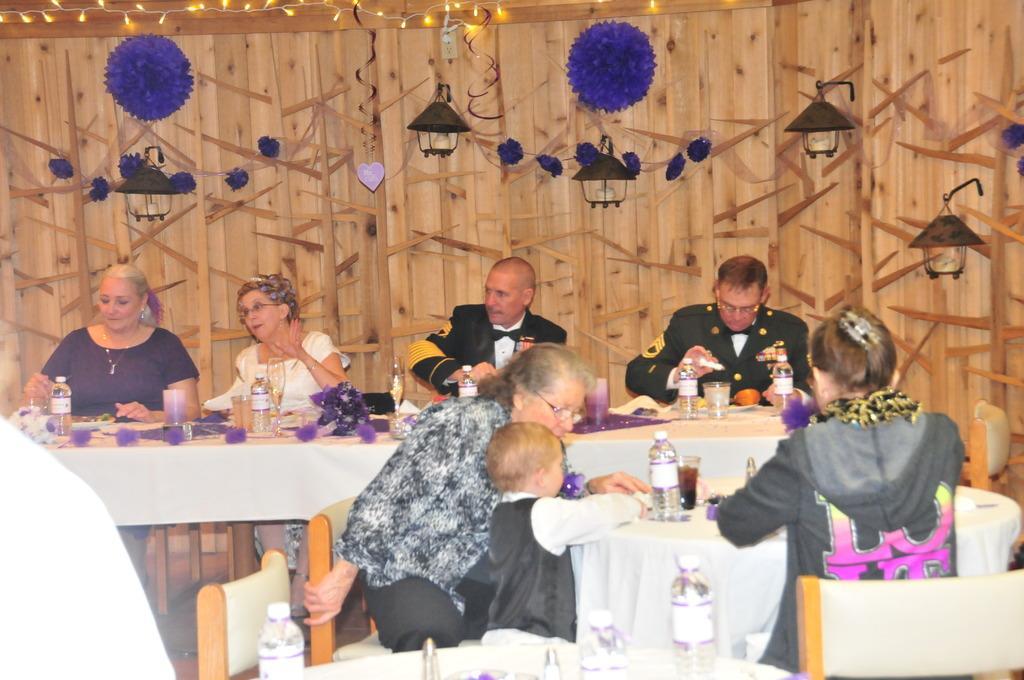How would you summarize this image in a sentence or two? In this image I can see few people are sitting on chairs. I can also see few tables and on the table I can see bottles and glasses. In the background I can see few decorations and few lights on this wall. 